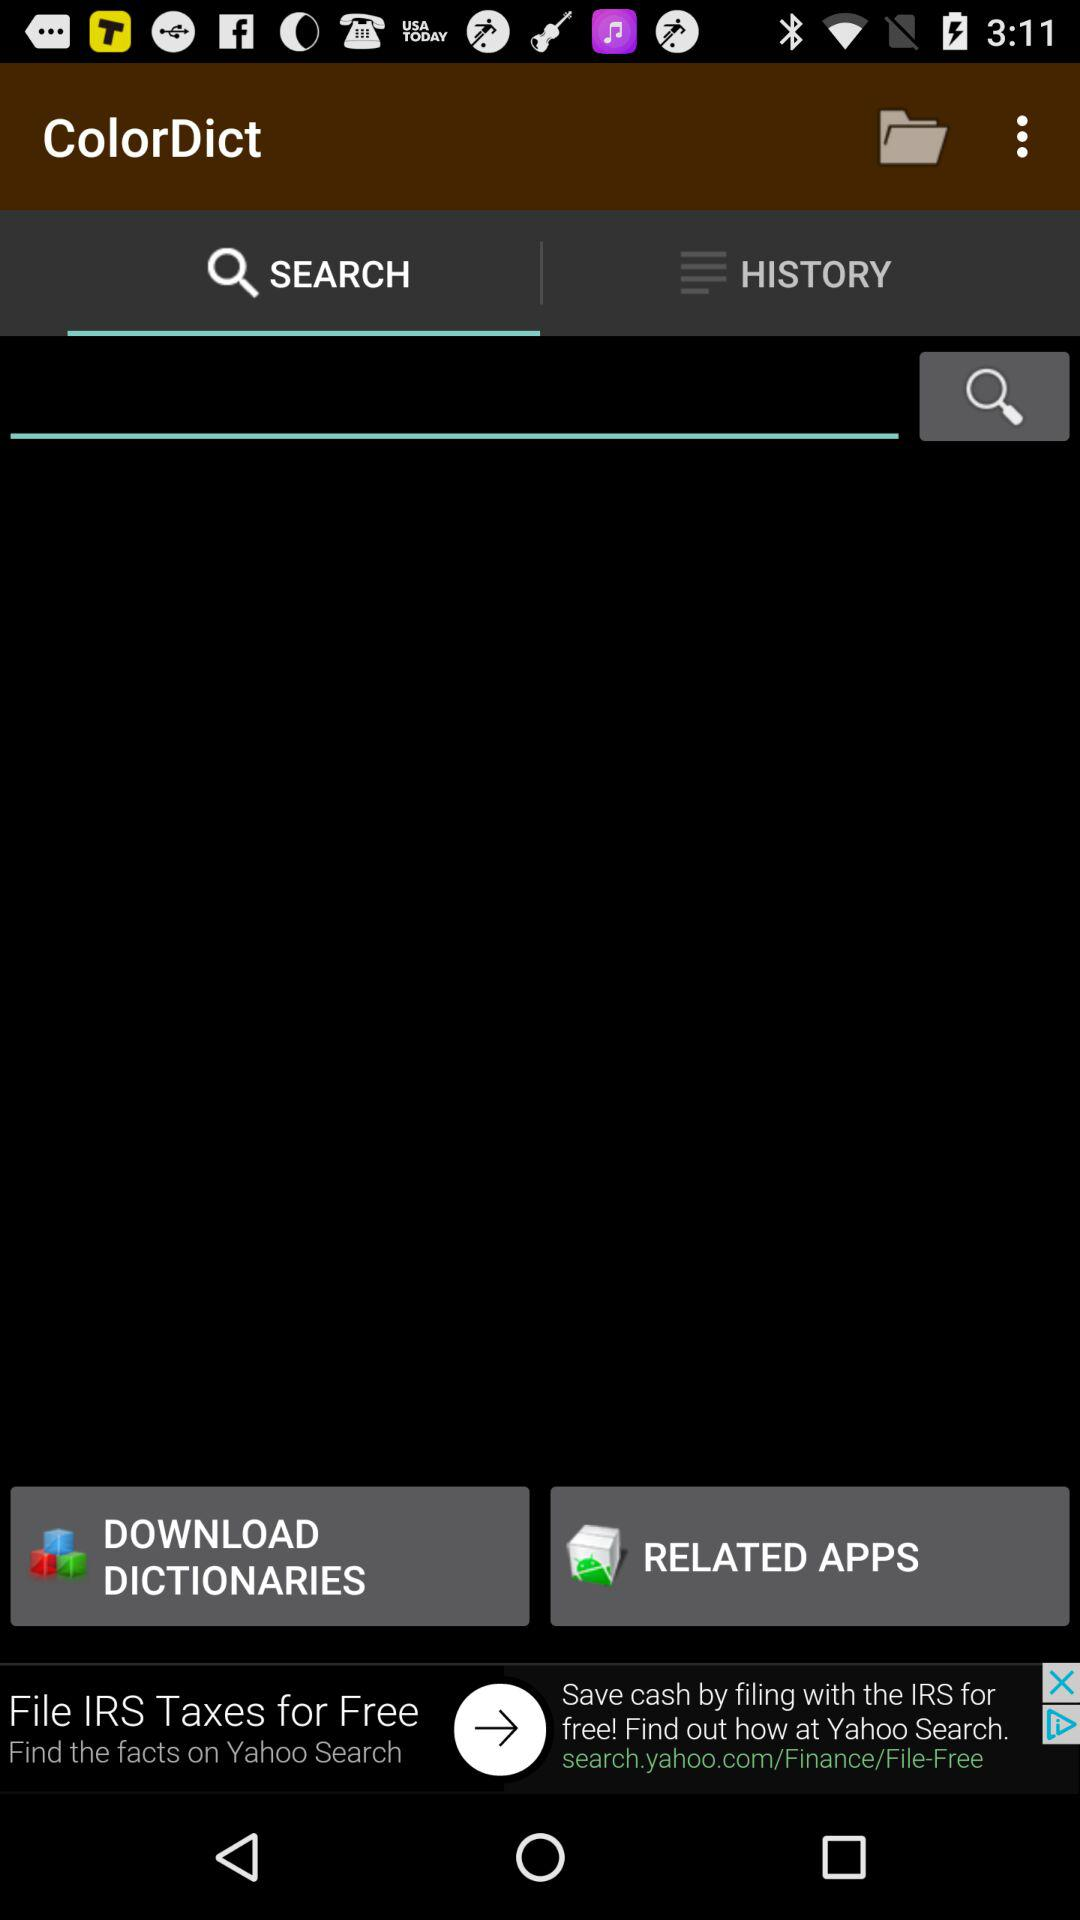What is the application name? The application name is "ColorDict". 